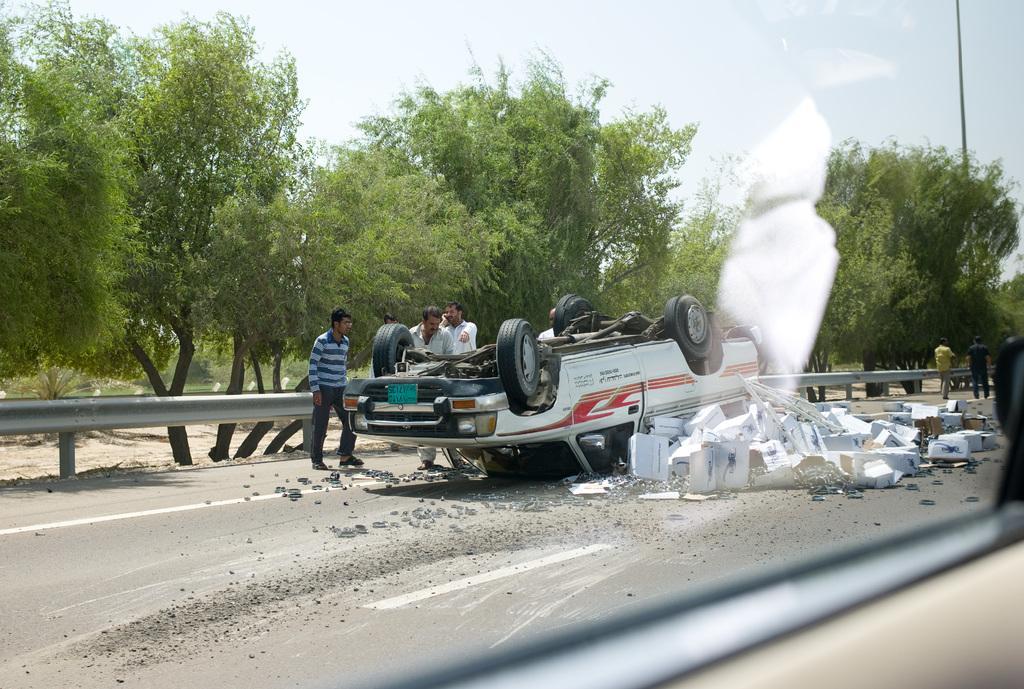How would you summarize this image in a sentence or two? In this image we can see a car, some stones, some boxes and a group of people standing on the road. We can also see a fence, a group of trees, a pole, some plants and the sky which looks cloudy. 